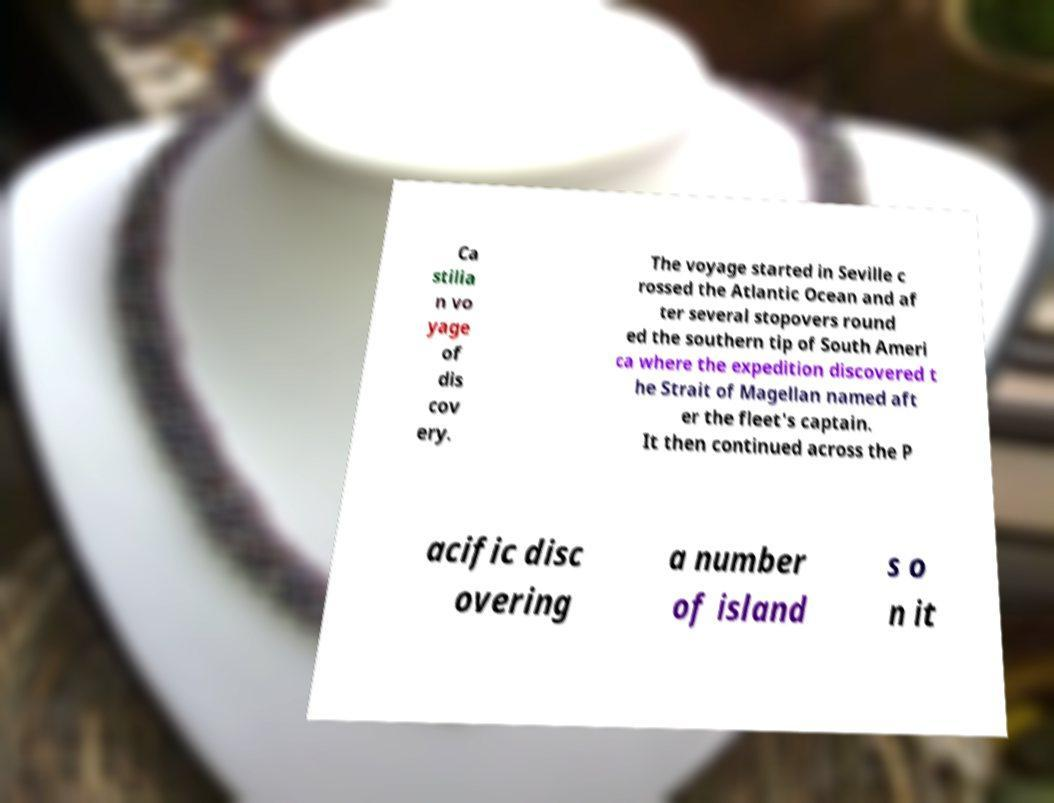For documentation purposes, I need the text within this image transcribed. Could you provide that? Ca stilia n vo yage of dis cov ery. The voyage started in Seville c rossed the Atlantic Ocean and af ter several stopovers round ed the southern tip of South Ameri ca where the expedition discovered t he Strait of Magellan named aft er the fleet's captain. It then continued across the P acific disc overing a number of island s o n it 